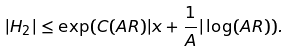<formula> <loc_0><loc_0><loc_500><loc_500>| H _ { 2 } | \leq \exp ( C ( A R ) | x + \frac { 1 } { A } | \log ( A R ) ) .</formula> 